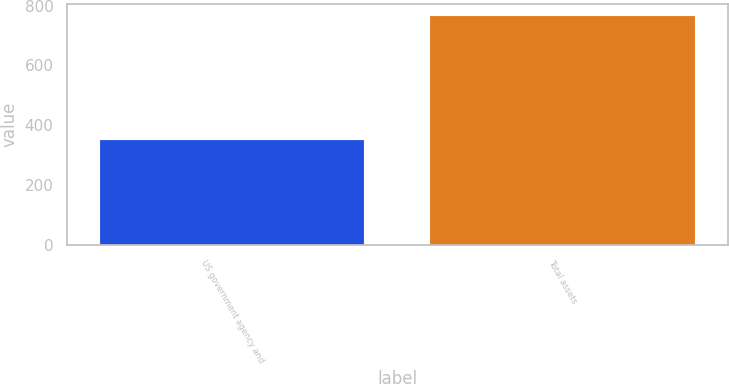<chart> <loc_0><loc_0><loc_500><loc_500><bar_chart><fcel>US government agency and<fcel>Total assets<nl><fcel>350<fcel>767<nl></chart> 